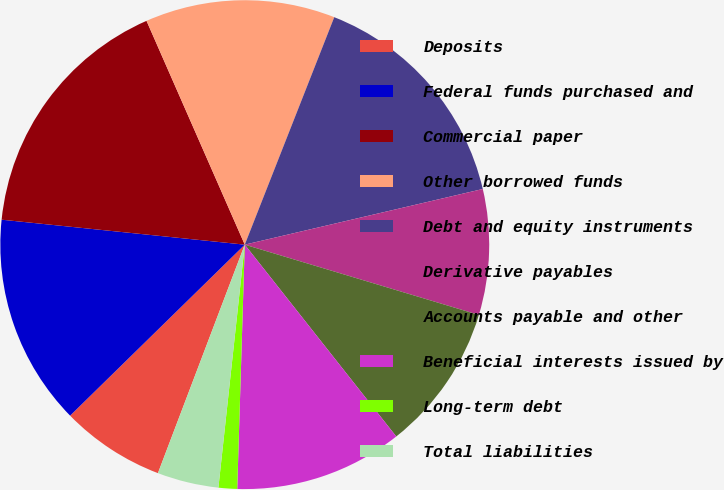<chart> <loc_0><loc_0><loc_500><loc_500><pie_chart><fcel>Deposits<fcel>Federal funds purchased and<fcel>Commercial paper<fcel>Other borrowed funds<fcel>Debt and equity instruments<fcel>Derivative payables<fcel>Accounts payable and other<fcel>Beneficial interests issued by<fcel>Long-term debt<fcel>Total liabilities<nl><fcel>6.89%<fcel>13.96%<fcel>16.79%<fcel>12.55%<fcel>15.38%<fcel>8.3%<fcel>9.72%<fcel>11.13%<fcel>1.23%<fcel>4.06%<nl></chart> 